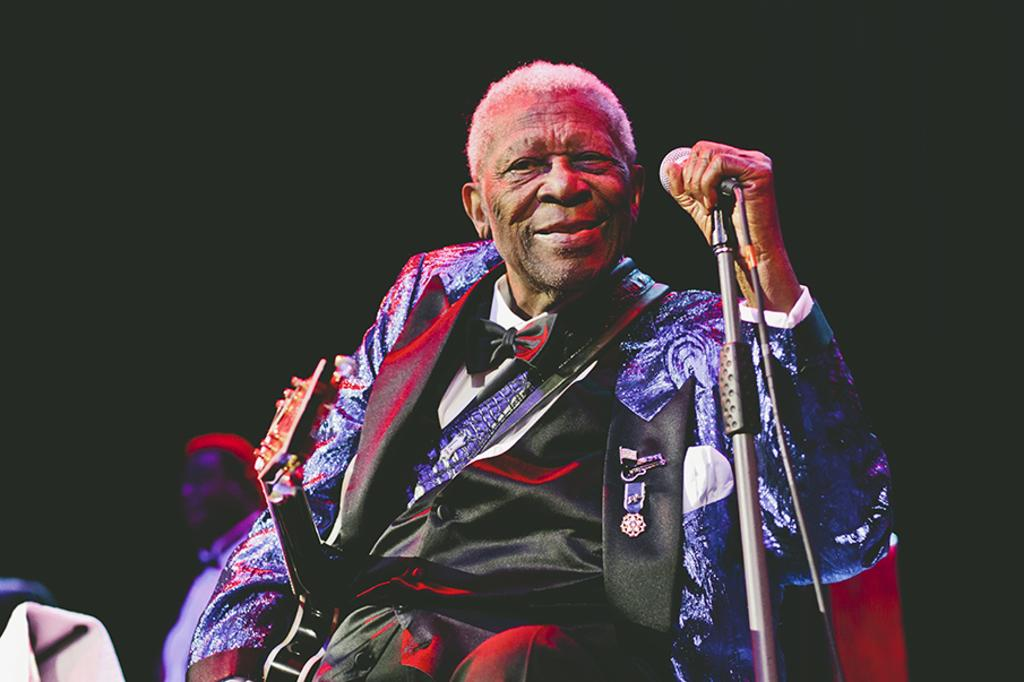Who is the main subject in the image? There is an old man in the image. What is the old man holding in the image? The old man is holding a microphone. Who might the old man be addressing or communicating with? The old man is looking at someone, so he might be addressing or communicating with that person. What type of animal can be seen in the background of the image? There is no animal visible in the image. 